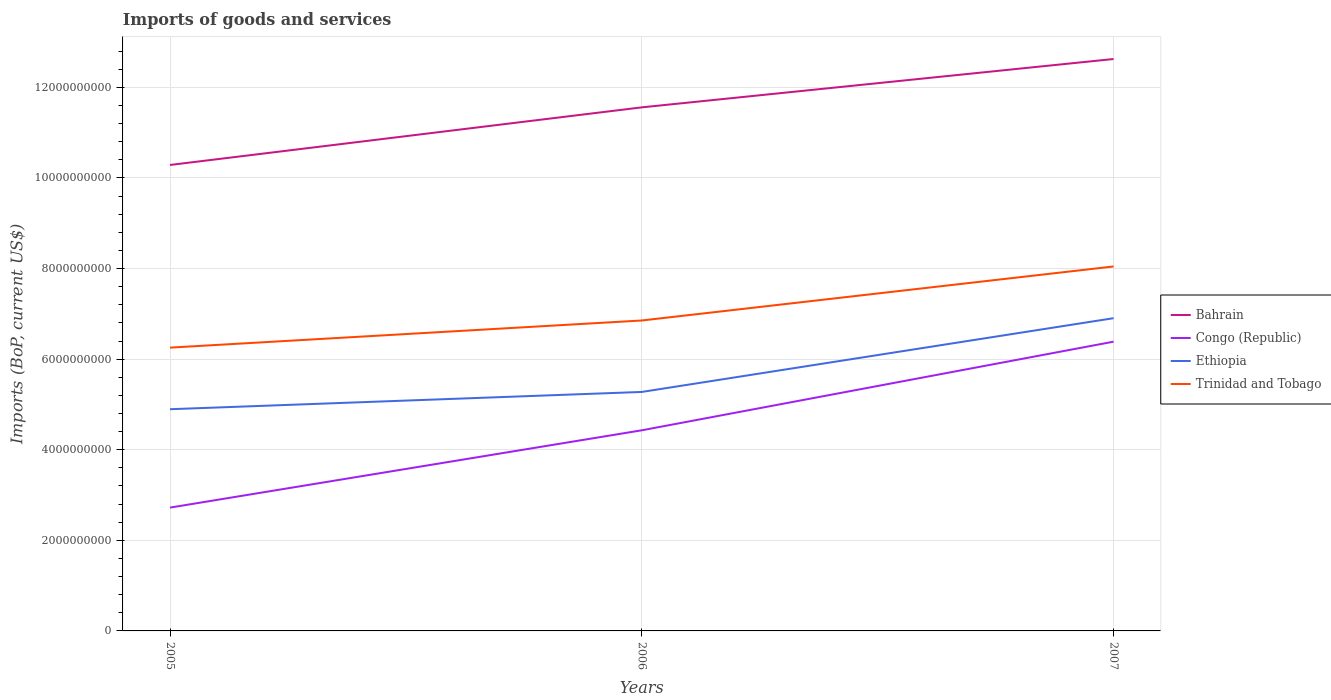Does the line corresponding to Ethiopia intersect with the line corresponding to Bahrain?
Your answer should be very brief. No. Is the number of lines equal to the number of legend labels?
Give a very brief answer. Yes. Across all years, what is the maximum amount spent on imports in Ethiopia?
Offer a very short reply. 4.89e+09. What is the total amount spent on imports in Bahrain in the graph?
Ensure brevity in your answer.  -1.27e+09. What is the difference between the highest and the second highest amount spent on imports in Ethiopia?
Make the answer very short. 2.01e+09. What is the difference between the highest and the lowest amount spent on imports in Ethiopia?
Make the answer very short. 1. How many years are there in the graph?
Give a very brief answer. 3. Does the graph contain any zero values?
Offer a very short reply. No. Where does the legend appear in the graph?
Your answer should be very brief. Center right. How many legend labels are there?
Your answer should be compact. 4. What is the title of the graph?
Give a very brief answer. Imports of goods and services. Does "European Union" appear as one of the legend labels in the graph?
Give a very brief answer. No. What is the label or title of the Y-axis?
Keep it short and to the point. Imports (BoP, current US$). What is the Imports (BoP, current US$) of Bahrain in 2005?
Offer a very short reply. 1.03e+1. What is the Imports (BoP, current US$) in Congo (Republic) in 2005?
Ensure brevity in your answer.  2.72e+09. What is the Imports (BoP, current US$) in Ethiopia in 2005?
Provide a short and direct response. 4.89e+09. What is the Imports (BoP, current US$) of Trinidad and Tobago in 2005?
Your answer should be compact. 6.25e+09. What is the Imports (BoP, current US$) of Bahrain in 2006?
Offer a terse response. 1.16e+1. What is the Imports (BoP, current US$) of Congo (Republic) in 2006?
Provide a short and direct response. 4.43e+09. What is the Imports (BoP, current US$) of Ethiopia in 2006?
Give a very brief answer. 5.28e+09. What is the Imports (BoP, current US$) in Trinidad and Tobago in 2006?
Ensure brevity in your answer.  6.85e+09. What is the Imports (BoP, current US$) in Bahrain in 2007?
Your answer should be very brief. 1.26e+1. What is the Imports (BoP, current US$) of Congo (Republic) in 2007?
Your response must be concise. 6.39e+09. What is the Imports (BoP, current US$) in Ethiopia in 2007?
Your answer should be compact. 6.90e+09. What is the Imports (BoP, current US$) in Trinidad and Tobago in 2007?
Provide a short and direct response. 8.05e+09. Across all years, what is the maximum Imports (BoP, current US$) of Bahrain?
Your answer should be very brief. 1.26e+1. Across all years, what is the maximum Imports (BoP, current US$) in Congo (Republic)?
Your answer should be very brief. 6.39e+09. Across all years, what is the maximum Imports (BoP, current US$) of Ethiopia?
Provide a succinct answer. 6.90e+09. Across all years, what is the maximum Imports (BoP, current US$) of Trinidad and Tobago?
Your answer should be compact. 8.05e+09. Across all years, what is the minimum Imports (BoP, current US$) of Bahrain?
Give a very brief answer. 1.03e+1. Across all years, what is the minimum Imports (BoP, current US$) of Congo (Republic)?
Your answer should be compact. 2.72e+09. Across all years, what is the minimum Imports (BoP, current US$) of Ethiopia?
Keep it short and to the point. 4.89e+09. Across all years, what is the minimum Imports (BoP, current US$) of Trinidad and Tobago?
Offer a very short reply. 6.25e+09. What is the total Imports (BoP, current US$) of Bahrain in the graph?
Your response must be concise. 3.45e+1. What is the total Imports (BoP, current US$) in Congo (Republic) in the graph?
Ensure brevity in your answer.  1.35e+1. What is the total Imports (BoP, current US$) of Ethiopia in the graph?
Provide a succinct answer. 1.71e+1. What is the total Imports (BoP, current US$) in Trinidad and Tobago in the graph?
Ensure brevity in your answer.  2.12e+1. What is the difference between the Imports (BoP, current US$) in Bahrain in 2005 and that in 2006?
Your response must be concise. -1.27e+09. What is the difference between the Imports (BoP, current US$) of Congo (Republic) in 2005 and that in 2006?
Your answer should be very brief. -1.71e+09. What is the difference between the Imports (BoP, current US$) of Ethiopia in 2005 and that in 2006?
Your response must be concise. -3.81e+08. What is the difference between the Imports (BoP, current US$) of Trinidad and Tobago in 2005 and that in 2006?
Your response must be concise. -5.99e+08. What is the difference between the Imports (BoP, current US$) in Bahrain in 2005 and that in 2007?
Keep it short and to the point. -2.34e+09. What is the difference between the Imports (BoP, current US$) of Congo (Republic) in 2005 and that in 2007?
Make the answer very short. -3.66e+09. What is the difference between the Imports (BoP, current US$) of Ethiopia in 2005 and that in 2007?
Give a very brief answer. -2.01e+09. What is the difference between the Imports (BoP, current US$) of Trinidad and Tobago in 2005 and that in 2007?
Keep it short and to the point. -1.79e+09. What is the difference between the Imports (BoP, current US$) of Bahrain in 2006 and that in 2007?
Ensure brevity in your answer.  -1.07e+09. What is the difference between the Imports (BoP, current US$) of Congo (Republic) in 2006 and that in 2007?
Offer a terse response. -1.96e+09. What is the difference between the Imports (BoP, current US$) of Ethiopia in 2006 and that in 2007?
Make the answer very short. -1.63e+09. What is the difference between the Imports (BoP, current US$) in Trinidad and Tobago in 2006 and that in 2007?
Ensure brevity in your answer.  -1.19e+09. What is the difference between the Imports (BoP, current US$) of Bahrain in 2005 and the Imports (BoP, current US$) of Congo (Republic) in 2006?
Offer a very short reply. 5.86e+09. What is the difference between the Imports (BoP, current US$) of Bahrain in 2005 and the Imports (BoP, current US$) of Ethiopia in 2006?
Provide a succinct answer. 5.01e+09. What is the difference between the Imports (BoP, current US$) of Bahrain in 2005 and the Imports (BoP, current US$) of Trinidad and Tobago in 2006?
Your answer should be very brief. 3.43e+09. What is the difference between the Imports (BoP, current US$) in Congo (Republic) in 2005 and the Imports (BoP, current US$) in Ethiopia in 2006?
Your answer should be very brief. -2.55e+09. What is the difference between the Imports (BoP, current US$) of Congo (Republic) in 2005 and the Imports (BoP, current US$) of Trinidad and Tobago in 2006?
Provide a short and direct response. -4.13e+09. What is the difference between the Imports (BoP, current US$) of Ethiopia in 2005 and the Imports (BoP, current US$) of Trinidad and Tobago in 2006?
Provide a short and direct response. -1.96e+09. What is the difference between the Imports (BoP, current US$) of Bahrain in 2005 and the Imports (BoP, current US$) of Congo (Republic) in 2007?
Provide a succinct answer. 3.90e+09. What is the difference between the Imports (BoP, current US$) in Bahrain in 2005 and the Imports (BoP, current US$) in Ethiopia in 2007?
Provide a short and direct response. 3.38e+09. What is the difference between the Imports (BoP, current US$) of Bahrain in 2005 and the Imports (BoP, current US$) of Trinidad and Tobago in 2007?
Provide a succinct answer. 2.24e+09. What is the difference between the Imports (BoP, current US$) of Congo (Republic) in 2005 and the Imports (BoP, current US$) of Ethiopia in 2007?
Your answer should be compact. -4.18e+09. What is the difference between the Imports (BoP, current US$) of Congo (Republic) in 2005 and the Imports (BoP, current US$) of Trinidad and Tobago in 2007?
Give a very brief answer. -5.32e+09. What is the difference between the Imports (BoP, current US$) of Ethiopia in 2005 and the Imports (BoP, current US$) of Trinidad and Tobago in 2007?
Keep it short and to the point. -3.15e+09. What is the difference between the Imports (BoP, current US$) in Bahrain in 2006 and the Imports (BoP, current US$) in Congo (Republic) in 2007?
Give a very brief answer. 5.17e+09. What is the difference between the Imports (BoP, current US$) in Bahrain in 2006 and the Imports (BoP, current US$) in Ethiopia in 2007?
Keep it short and to the point. 4.65e+09. What is the difference between the Imports (BoP, current US$) of Bahrain in 2006 and the Imports (BoP, current US$) of Trinidad and Tobago in 2007?
Your response must be concise. 3.51e+09. What is the difference between the Imports (BoP, current US$) in Congo (Republic) in 2006 and the Imports (BoP, current US$) in Ethiopia in 2007?
Offer a very short reply. -2.48e+09. What is the difference between the Imports (BoP, current US$) of Congo (Republic) in 2006 and the Imports (BoP, current US$) of Trinidad and Tobago in 2007?
Give a very brief answer. -3.62e+09. What is the difference between the Imports (BoP, current US$) of Ethiopia in 2006 and the Imports (BoP, current US$) of Trinidad and Tobago in 2007?
Keep it short and to the point. -2.77e+09. What is the average Imports (BoP, current US$) of Bahrain per year?
Your answer should be very brief. 1.15e+1. What is the average Imports (BoP, current US$) of Congo (Republic) per year?
Your answer should be very brief. 4.51e+09. What is the average Imports (BoP, current US$) of Ethiopia per year?
Your response must be concise. 5.69e+09. What is the average Imports (BoP, current US$) of Trinidad and Tobago per year?
Your response must be concise. 7.05e+09. In the year 2005, what is the difference between the Imports (BoP, current US$) of Bahrain and Imports (BoP, current US$) of Congo (Republic)?
Your answer should be very brief. 7.56e+09. In the year 2005, what is the difference between the Imports (BoP, current US$) in Bahrain and Imports (BoP, current US$) in Ethiopia?
Provide a short and direct response. 5.39e+09. In the year 2005, what is the difference between the Imports (BoP, current US$) of Bahrain and Imports (BoP, current US$) of Trinidad and Tobago?
Provide a succinct answer. 4.03e+09. In the year 2005, what is the difference between the Imports (BoP, current US$) in Congo (Republic) and Imports (BoP, current US$) in Ethiopia?
Give a very brief answer. -2.17e+09. In the year 2005, what is the difference between the Imports (BoP, current US$) of Congo (Republic) and Imports (BoP, current US$) of Trinidad and Tobago?
Give a very brief answer. -3.53e+09. In the year 2005, what is the difference between the Imports (BoP, current US$) in Ethiopia and Imports (BoP, current US$) in Trinidad and Tobago?
Make the answer very short. -1.36e+09. In the year 2006, what is the difference between the Imports (BoP, current US$) of Bahrain and Imports (BoP, current US$) of Congo (Republic)?
Provide a short and direct response. 7.13e+09. In the year 2006, what is the difference between the Imports (BoP, current US$) of Bahrain and Imports (BoP, current US$) of Ethiopia?
Provide a succinct answer. 6.28e+09. In the year 2006, what is the difference between the Imports (BoP, current US$) in Bahrain and Imports (BoP, current US$) in Trinidad and Tobago?
Make the answer very short. 4.71e+09. In the year 2006, what is the difference between the Imports (BoP, current US$) of Congo (Republic) and Imports (BoP, current US$) of Ethiopia?
Your response must be concise. -8.47e+08. In the year 2006, what is the difference between the Imports (BoP, current US$) in Congo (Republic) and Imports (BoP, current US$) in Trinidad and Tobago?
Your answer should be very brief. -2.42e+09. In the year 2006, what is the difference between the Imports (BoP, current US$) of Ethiopia and Imports (BoP, current US$) of Trinidad and Tobago?
Your answer should be compact. -1.58e+09. In the year 2007, what is the difference between the Imports (BoP, current US$) in Bahrain and Imports (BoP, current US$) in Congo (Republic)?
Offer a terse response. 6.24e+09. In the year 2007, what is the difference between the Imports (BoP, current US$) in Bahrain and Imports (BoP, current US$) in Ethiopia?
Keep it short and to the point. 5.72e+09. In the year 2007, what is the difference between the Imports (BoP, current US$) in Bahrain and Imports (BoP, current US$) in Trinidad and Tobago?
Provide a short and direct response. 4.58e+09. In the year 2007, what is the difference between the Imports (BoP, current US$) of Congo (Republic) and Imports (BoP, current US$) of Ethiopia?
Offer a terse response. -5.19e+08. In the year 2007, what is the difference between the Imports (BoP, current US$) of Congo (Republic) and Imports (BoP, current US$) of Trinidad and Tobago?
Offer a very short reply. -1.66e+09. In the year 2007, what is the difference between the Imports (BoP, current US$) in Ethiopia and Imports (BoP, current US$) in Trinidad and Tobago?
Ensure brevity in your answer.  -1.14e+09. What is the ratio of the Imports (BoP, current US$) in Bahrain in 2005 to that in 2006?
Your answer should be very brief. 0.89. What is the ratio of the Imports (BoP, current US$) in Congo (Republic) in 2005 to that in 2006?
Keep it short and to the point. 0.61. What is the ratio of the Imports (BoP, current US$) of Ethiopia in 2005 to that in 2006?
Your answer should be very brief. 0.93. What is the ratio of the Imports (BoP, current US$) in Trinidad and Tobago in 2005 to that in 2006?
Your answer should be compact. 0.91. What is the ratio of the Imports (BoP, current US$) of Bahrain in 2005 to that in 2007?
Your answer should be very brief. 0.81. What is the ratio of the Imports (BoP, current US$) of Congo (Republic) in 2005 to that in 2007?
Give a very brief answer. 0.43. What is the ratio of the Imports (BoP, current US$) of Ethiopia in 2005 to that in 2007?
Your response must be concise. 0.71. What is the ratio of the Imports (BoP, current US$) of Trinidad and Tobago in 2005 to that in 2007?
Your answer should be compact. 0.78. What is the ratio of the Imports (BoP, current US$) of Bahrain in 2006 to that in 2007?
Make the answer very short. 0.92. What is the ratio of the Imports (BoP, current US$) of Congo (Republic) in 2006 to that in 2007?
Your answer should be compact. 0.69. What is the ratio of the Imports (BoP, current US$) of Ethiopia in 2006 to that in 2007?
Keep it short and to the point. 0.76. What is the ratio of the Imports (BoP, current US$) of Trinidad and Tobago in 2006 to that in 2007?
Offer a terse response. 0.85. What is the difference between the highest and the second highest Imports (BoP, current US$) of Bahrain?
Your answer should be very brief. 1.07e+09. What is the difference between the highest and the second highest Imports (BoP, current US$) in Congo (Republic)?
Keep it short and to the point. 1.96e+09. What is the difference between the highest and the second highest Imports (BoP, current US$) of Ethiopia?
Provide a succinct answer. 1.63e+09. What is the difference between the highest and the second highest Imports (BoP, current US$) in Trinidad and Tobago?
Provide a short and direct response. 1.19e+09. What is the difference between the highest and the lowest Imports (BoP, current US$) of Bahrain?
Offer a terse response. 2.34e+09. What is the difference between the highest and the lowest Imports (BoP, current US$) of Congo (Republic)?
Provide a succinct answer. 3.66e+09. What is the difference between the highest and the lowest Imports (BoP, current US$) in Ethiopia?
Your response must be concise. 2.01e+09. What is the difference between the highest and the lowest Imports (BoP, current US$) of Trinidad and Tobago?
Offer a terse response. 1.79e+09. 